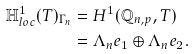Convert formula to latex. <formula><loc_0><loc_0><loc_500><loc_500>\mathbb { H } ^ { 1 } _ { l o c } ( T ) _ { \Gamma _ { n } } & = H ^ { 1 } ( \mathbb { Q } _ { n , p } , T ) \\ & = \Lambda _ { n } e _ { 1 } \oplus \Lambda _ { n } e _ { 2 } .</formula> 